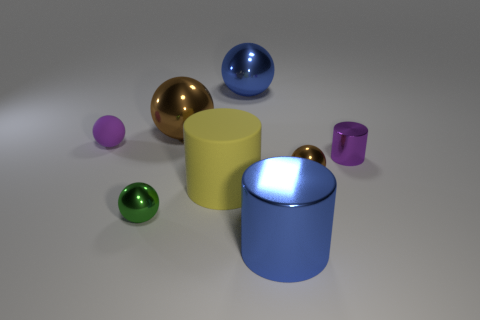Are there any tiny green things behind the purple shiny thing?
Give a very brief answer. No. How many things are purple things behind the tiny purple metal thing or tiny shiny things that are in front of the purple metallic object?
Offer a very short reply. 3. How many cylinders have the same color as the matte sphere?
Offer a terse response. 1. There is a matte object that is the same shape as the small brown metallic thing; what color is it?
Make the answer very short. Purple. There is a object that is both in front of the large yellow thing and on the right side of the green object; what shape is it?
Keep it short and to the point. Cylinder. Are there more green metal things than big brown matte balls?
Provide a short and direct response. Yes. What material is the yellow cylinder?
Provide a short and direct response. Rubber. There is a yellow matte object that is the same shape as the purple metallic thing; what size is it?
Provide a short and direct response. Large. Are there any brown metal objects to the right of the brown shiny object behind the tiny purple metallic object?
Offer a very short reply. Yes. Is the color of the small matte sphere the same as the small shiny cylinder?
Your answer should be very brief. Yes. 